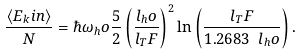Convert formula to latex. <formula><loc_0><loc_0><loc_500><loc_500>\frac { \langle E _ { k } i n \rangle } { N } = \hbar { \omega } _ { h } o \frac { 5 } { 2 } \left ( \frac { l _ { h } o } { l _ { T } F } \right ) ^ { 2 } \ln \left ( \frac { l _ { T } F } { 1 . 2 6 8 3 \ l _ { h } o } \right ) .</formula> 